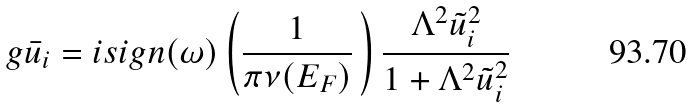<formula> <loc_0><loc_0><loc_500><loc_500>g \bar { u } _ { i } = i s i g n ( \omega ) \left ( \frac { 1 } { \pi \nu ( E _ { F } ) } \, \right ) \frac { \Lambda ^ { 2 } \tilde { u } _ { i } ^ { 2 } } { 1 + \Lambda ^ { 2 } \tilde { u } _ { i } ^ { 2 } } \,</formula> 